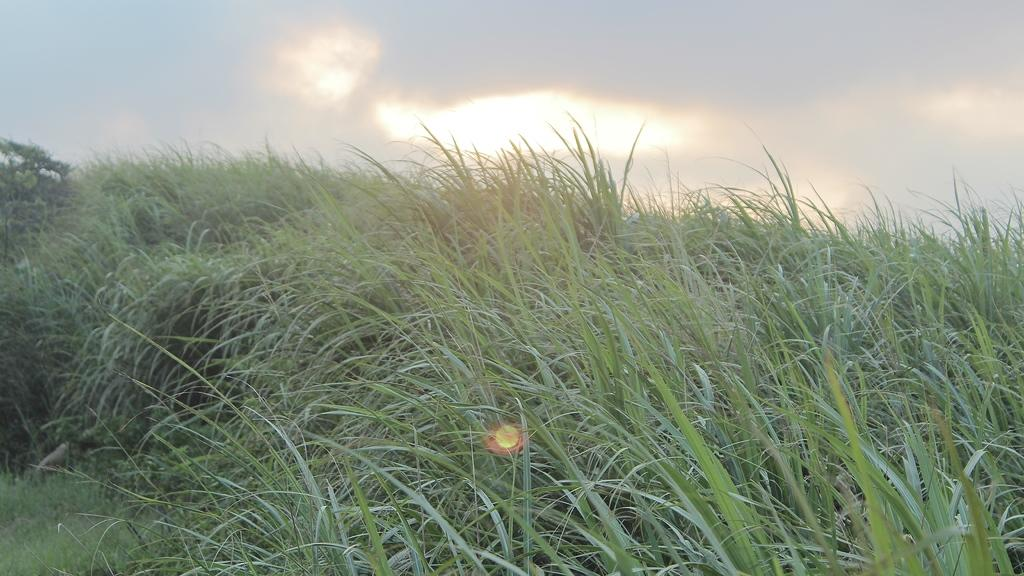What type of vegetation can be seen in the image? There is grass in the image. What can be seen in the sky in the background of the image? There are clouds in the sky in the background of the image. Where is the vein located in the image? There is no vein present in the image. What type of shelf can be seen in the image? There is no shelf present in the image. 